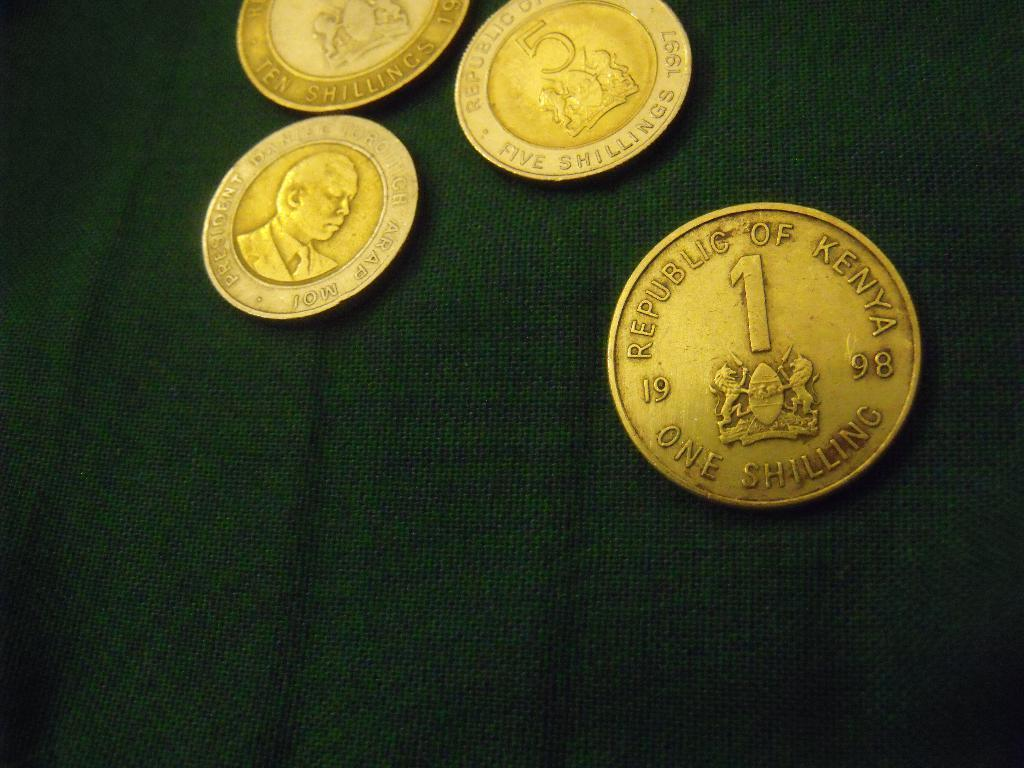<image>
Summarize the visual content of the image. The gold coin has the year 1998 on it 